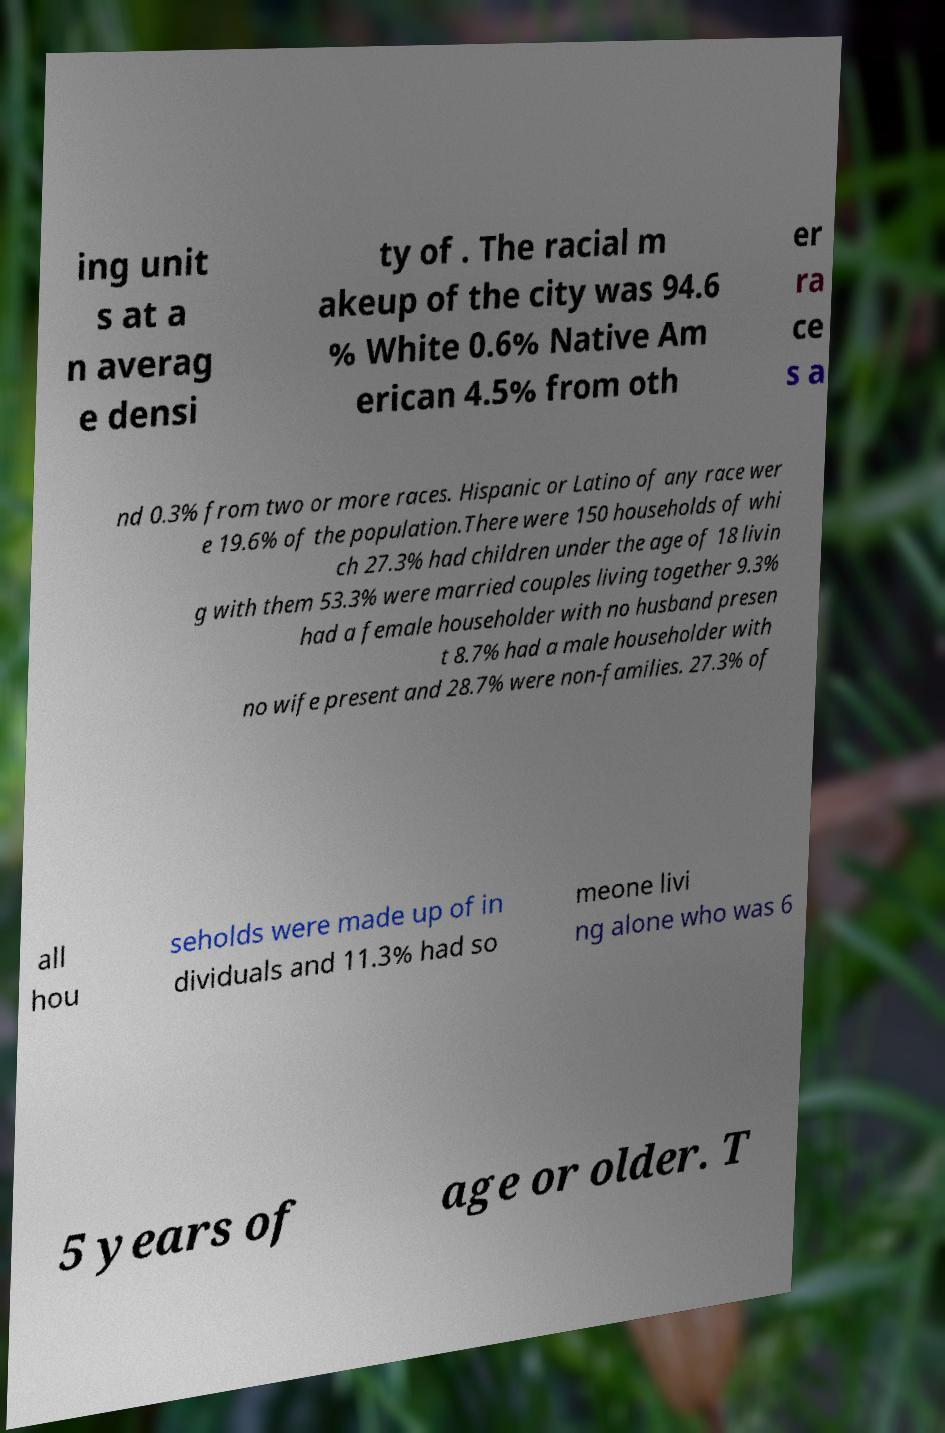Can you accurately transcribe the text from the provided image for me? ing unit s at a n averag e densi ty of . The racial m akeup of the city was 94.6 % White 0.6% Native Am erican 4.5% from oth er ra ce s a nd 0.3% from two or more races. Hispanic or Latino of any race wer e 19.6% of the population.There were 150 households of whi ch 27.3% had children under the age of 18 livin g with them 53.3% were married couples living together 9.3% had a female householder with no husband presen t 8.7% had a male householder with no wife present and 28.7% were non-families. 27.3% of all hou seholds were made up of in dividuals and 11.3% had so meone livi ng alone who was 6 5 years of age or older. T 